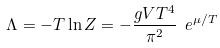<formula> <loc_0><loc_0><loc_500><loc_500>\Lambda = - T \ln Z = - \frac { g V T ^ { 4 } } { \pi ^ { 2 } } \ e ^ { \mu / T }</formula> 